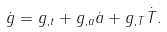Convert formula to latex. <formula><loc_0><loc_0><loc_500><loc_500>\dot { g } = g _ { , t } + g _ { , a } \dot { a } + g _ { , T } \dot { T } .</formula> 